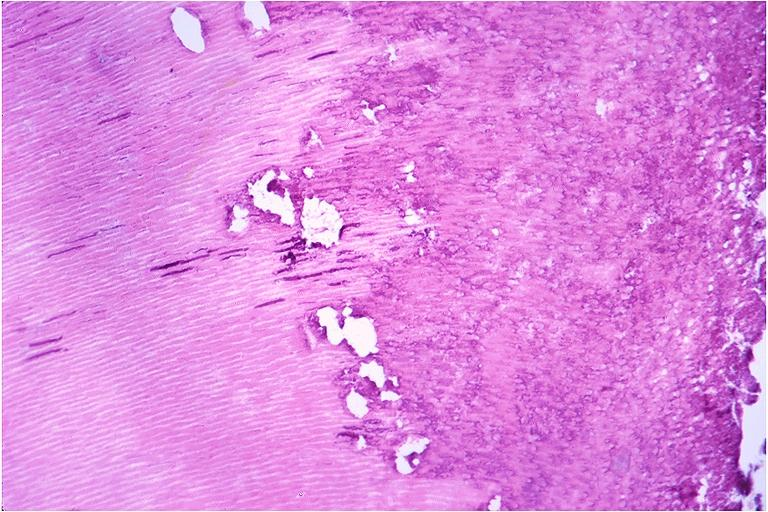where is this?
Answer the question using a single word or phrase. Oral 